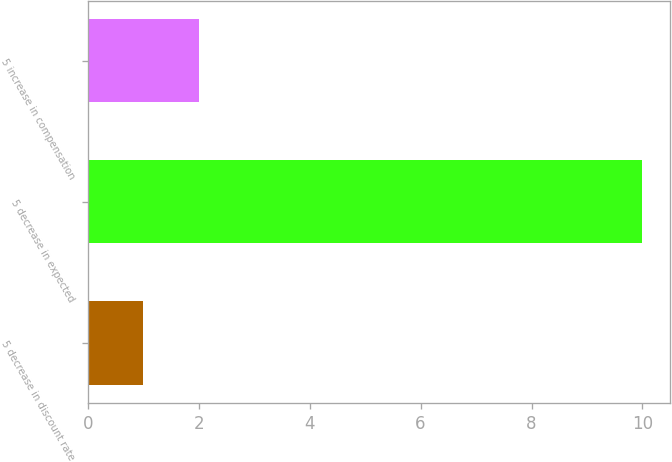<chart> <loc_0><loc_0><loc_500><loc_500><bar_chart><fcel>5 decrease in discount rate<fcel>5 decrease in expected<fcel>5 increase in compensation<nl><fcel>1<fcel>10<fcel>2<nl></chart> 